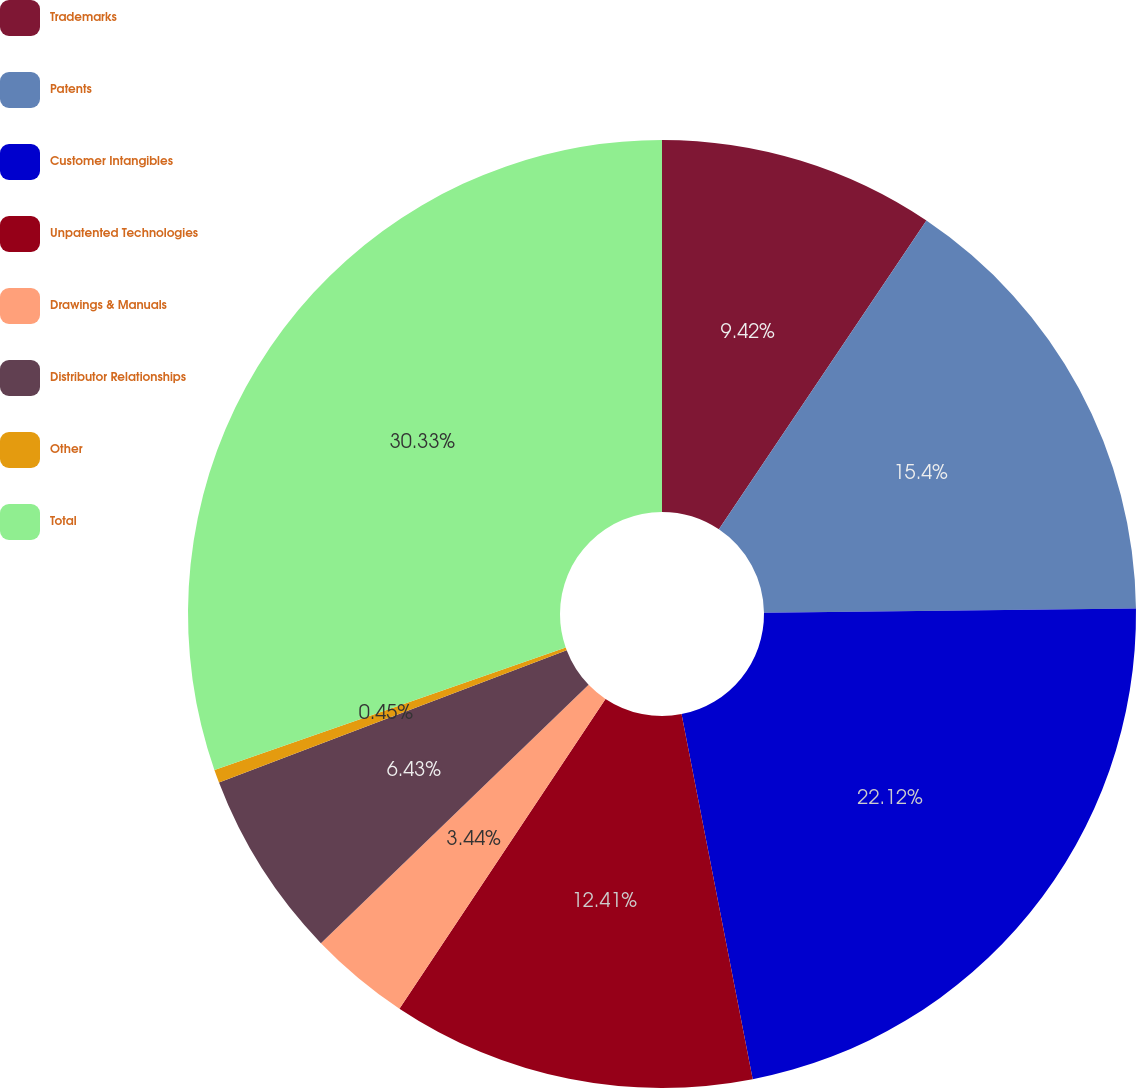<chart> <loc_0><loc_0><loc_500><loc_500><pie_chart><fcel>Trademarks<fcel>Patents<fcel>Customer Intangibles<fcel>Unpatented Technologies<fcel>Drawings & Manuals<fcel>Distributor Relationships<fcel>Other<fcel>Total<nl><fcel>9.42%<fcel>15.4%<fcel>22.12%<fcel>12.41%<fcel>3.44%<fcel>6.43%<fcel>0.45%<fcel>30.34%<nl></chart> 